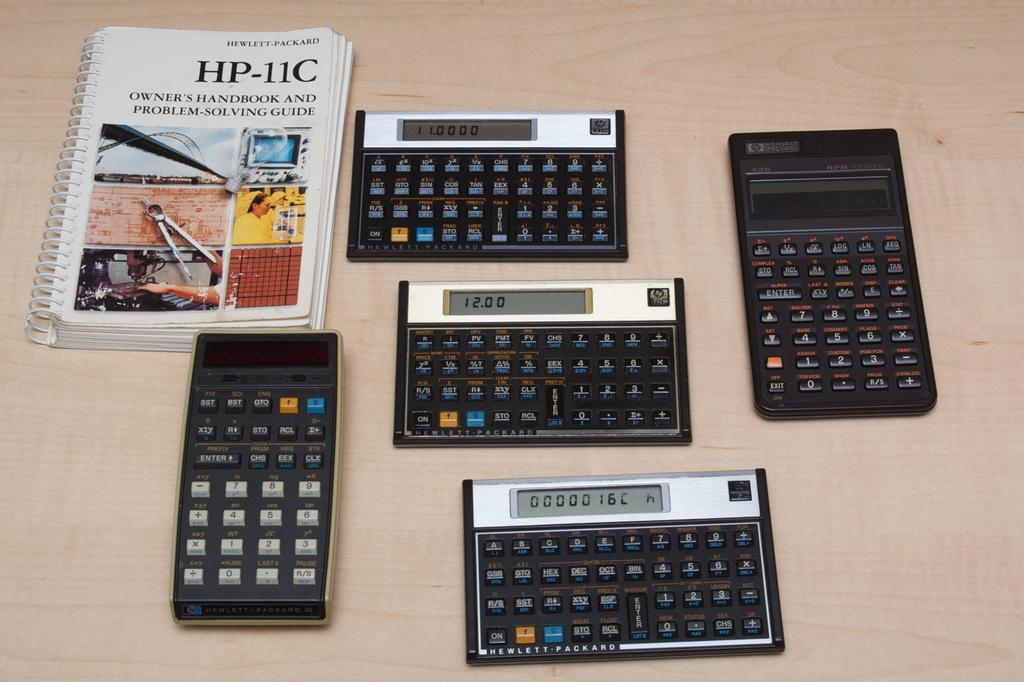<image>
Provide a brief description of the given image. Five calculators on a table with one saying 12.00. 